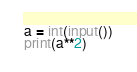Convert code to text. <code><loc_0><loc_0><loc_500><loc_500><_Python_>a = int(input())
print(a**2)</code> 